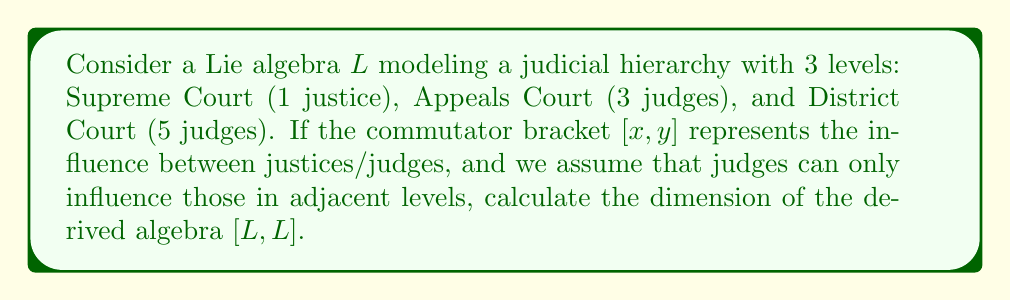Help me with this question. Let's approach this step-by-step:

1) First, we need to understand the structure of our Lie algebra $L$. It has a total of $1 + 3 + 5 = 9$ basis elements, each representing a judge or justice.

2) The derived algebra $[L,L]$ is generated by all possible commutators $[x,y]$ where $x,y \in L$.

3) Given the constraint that judges can only influence those in adjacent levels, we have the following possible commutators:
   - Supreme Court justice with Appeals Court judges: 3 commutators
   - Appeals Court judges with District Court judges: $3 \times 5 = 15$ commutators

4) Each commutator represents a unique direction of influence, so these are linearly independent.

5) The total number of linearly independent commutators is thus $3 + 15 = 18$.

6) However, in a Lie algebra, $[x,y] = -[y,x]$, so we've double-counted each interaction. The actual number of linearly independent elements in $[L,L]$ is half of this.

7) Therefore, the dimension of $[L,L]$ is $18 / 2 = 9$.

This result interestingly matches the dimension of the original Lie algebra $L$, suggesting that the derived algebra in this case is equal to the original algebra. This could be interpreted as the judicial system being "fully connected" in terms of influence, despite the hierarchical structure.
Answer: The dimension of the derived algebra $[L,L]$ is 9. 